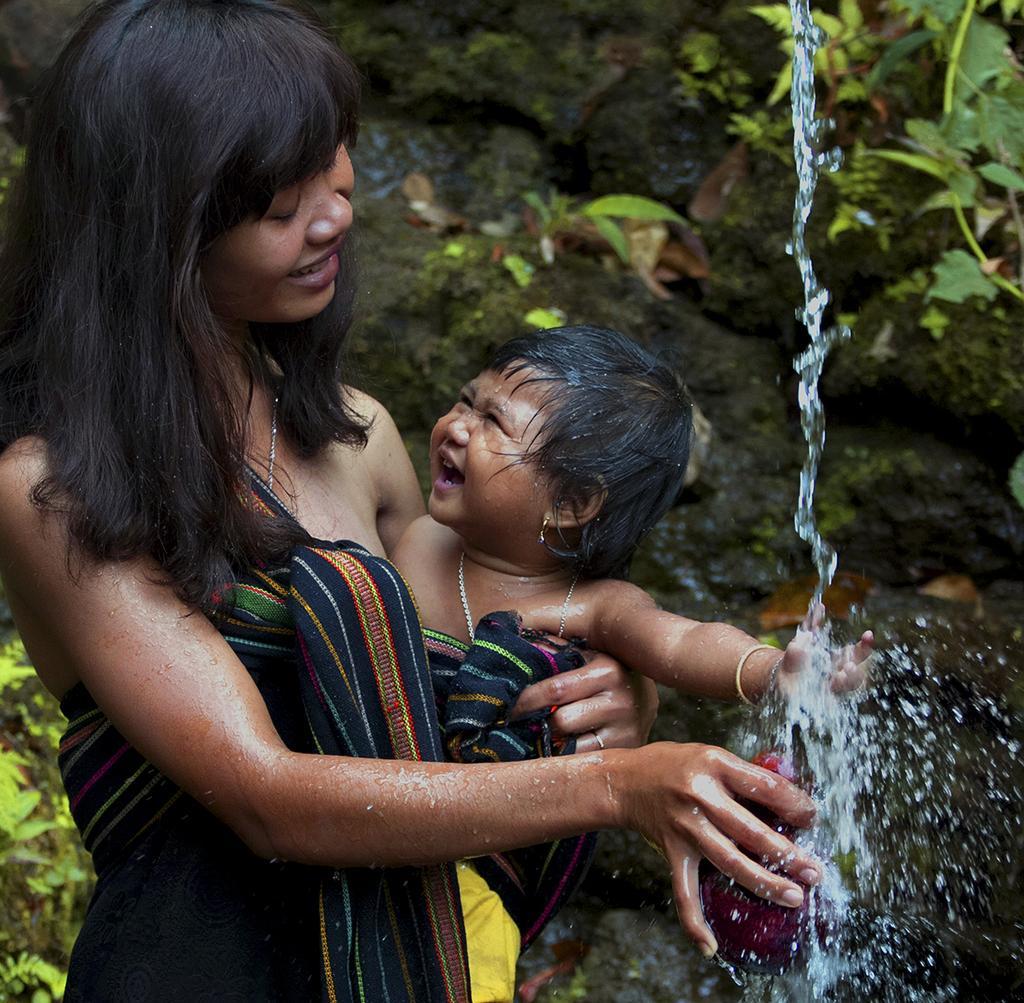In one or two sentences, can you explain what this image depicts? There is a woman standing and holding a baby and we can see water. Background we can see leaves. 